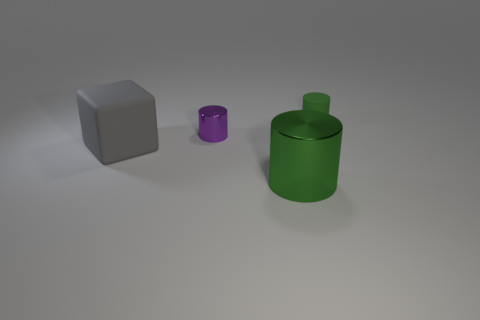Subtract all purple cylinders. How many cylinders are left? 2 Subtract all purple cylinders. How many cylinders are left? 2 Subtract all blocks. How many objects are left? 3 Add 3 green things. How many objects exist? 7 Subtract 2 green cylinders. How many objects are left? 2 Subtract 1 cylinders. How many cylinders are left? 2 Subtract all yellow cylinders. Subtract all green blocks. How many cylinders are left? 3 Subtract all red cubes. How many purple cylinders are left? 1 Subtract all gray things. Subtract all big cylinders. How many objects are left? 2 Add 2 tiny cylinders. How many tiny cylinders are left? 4 